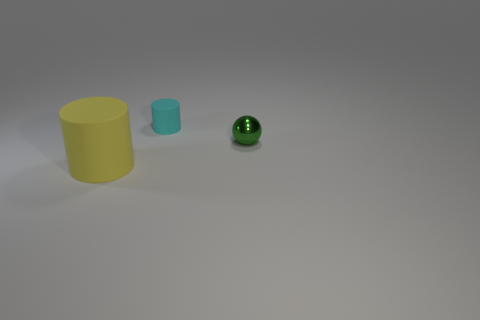Add 2 big gray objects. How many objects exist? 5 Subtract all spheres. How many objects are left? 2 Add 1 small cyan matte objects. How many small cyan matte objects are left? 2 Add 1 big objects. How many big objects exist? 2 Subtract 1 yellow cylinders. How many objects are left? 2 Subtract all big matte objects. Subtract all green spheres. How many objects are left? 1 